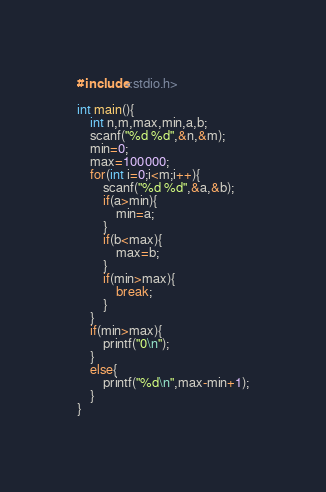Convert code to text. <code><loc_0><loc_0><loc_500><loc_500><_C_>#include<stdio.h>

int main(){
    int n,m,max,min,a,b;
    scanf("%d %d",&n,&m);
    min=0;
    max=100000;
    for(int i=0;i<m;i++){
        scanf("%d %d",&a,&b);
        if(a>min){
            min=a;
        }
        if(b<max){
            max=b;
        }
        if(min>max){
            break;
        }
    }
    if(min>max){
        printf("0\n");
    }
    else{
        printf("%d\n",max-min+1);
    }
}
</code> 